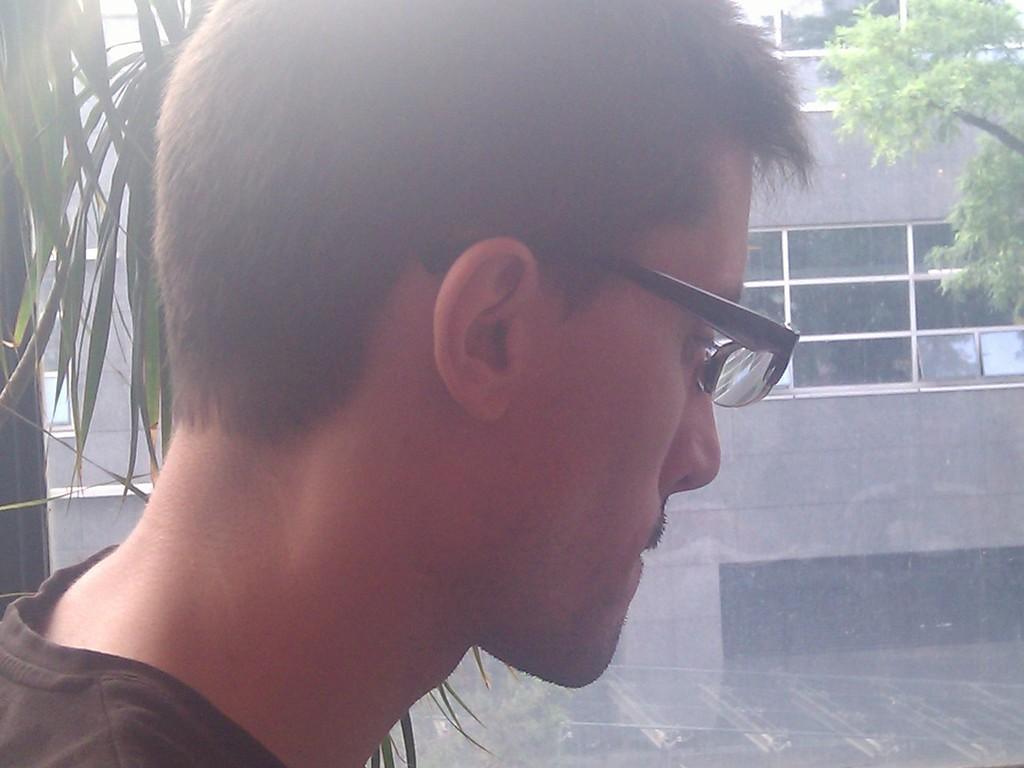What is present in the image? There is a person in the image. Can you describe the person's clothing? The person is wearing a T-shirt. What accessory is the person wearing? The person is wearing spectacles. What can be seen in the background of the image? There is a building with glass windows and trees in the background of the image. What type of sign is the tramp holding in the image? There is no tramp or sign present in the image; it features a person wearing a T-shirt and spectacles with a background of a building and trees. 